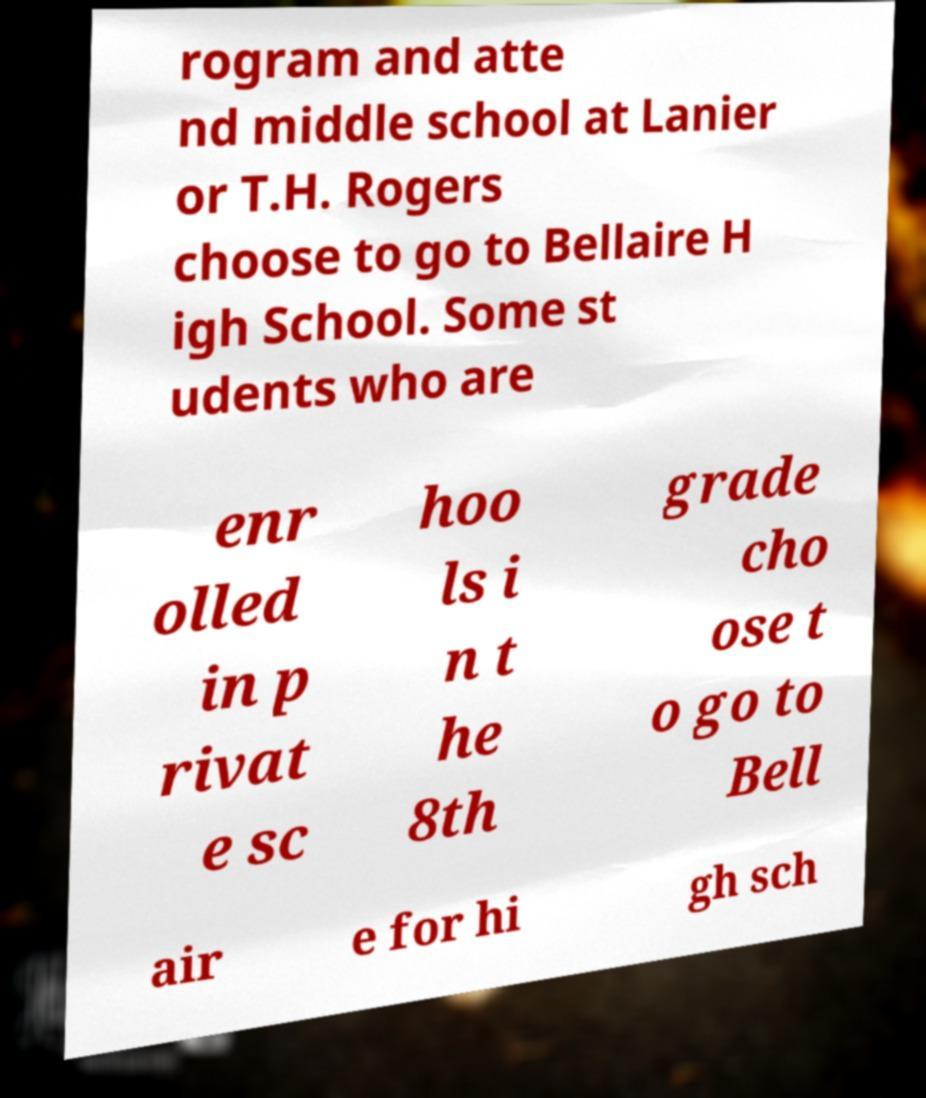There's text embedded in this image that I need extracted. Can you transcribe it verbatim? rogram and atte nd middle school at Lanier or T.H. Rogers choose to go to Bellaire H igh School. Some st udents who are enr olled in p rivat e sc hoo ls i n t he 8th grade cho ose t o go to Bell air e for hi gh sch 